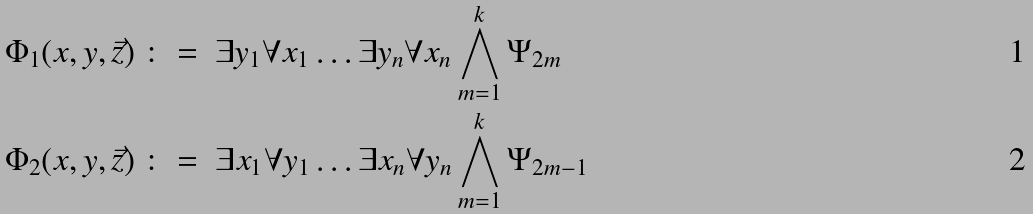<formula> <loc_0><loc_0><loc_500><loc_500>\Phi _ { 1 } ( x , y , \vec { z } ) \ & \colon = \ \exists y _ { 1 } \forall x _ { 1 } \dots \exists y _ { n } \forall x _ { n } \bigwedge _ { m = 1 } ^ { k } \Psi _ { 2 m } \\ \Phi _ { 2 } ( x , y , \vec { z } ) \ & \colon = \ \exists x _ { 1 } \forall y _ { 1 } \dots \exists x _ { n } \forall y _ { n } \bigwedge _ { m = 1 } ^ { k } \Psi _ { 2 m - 1 }</formula> 